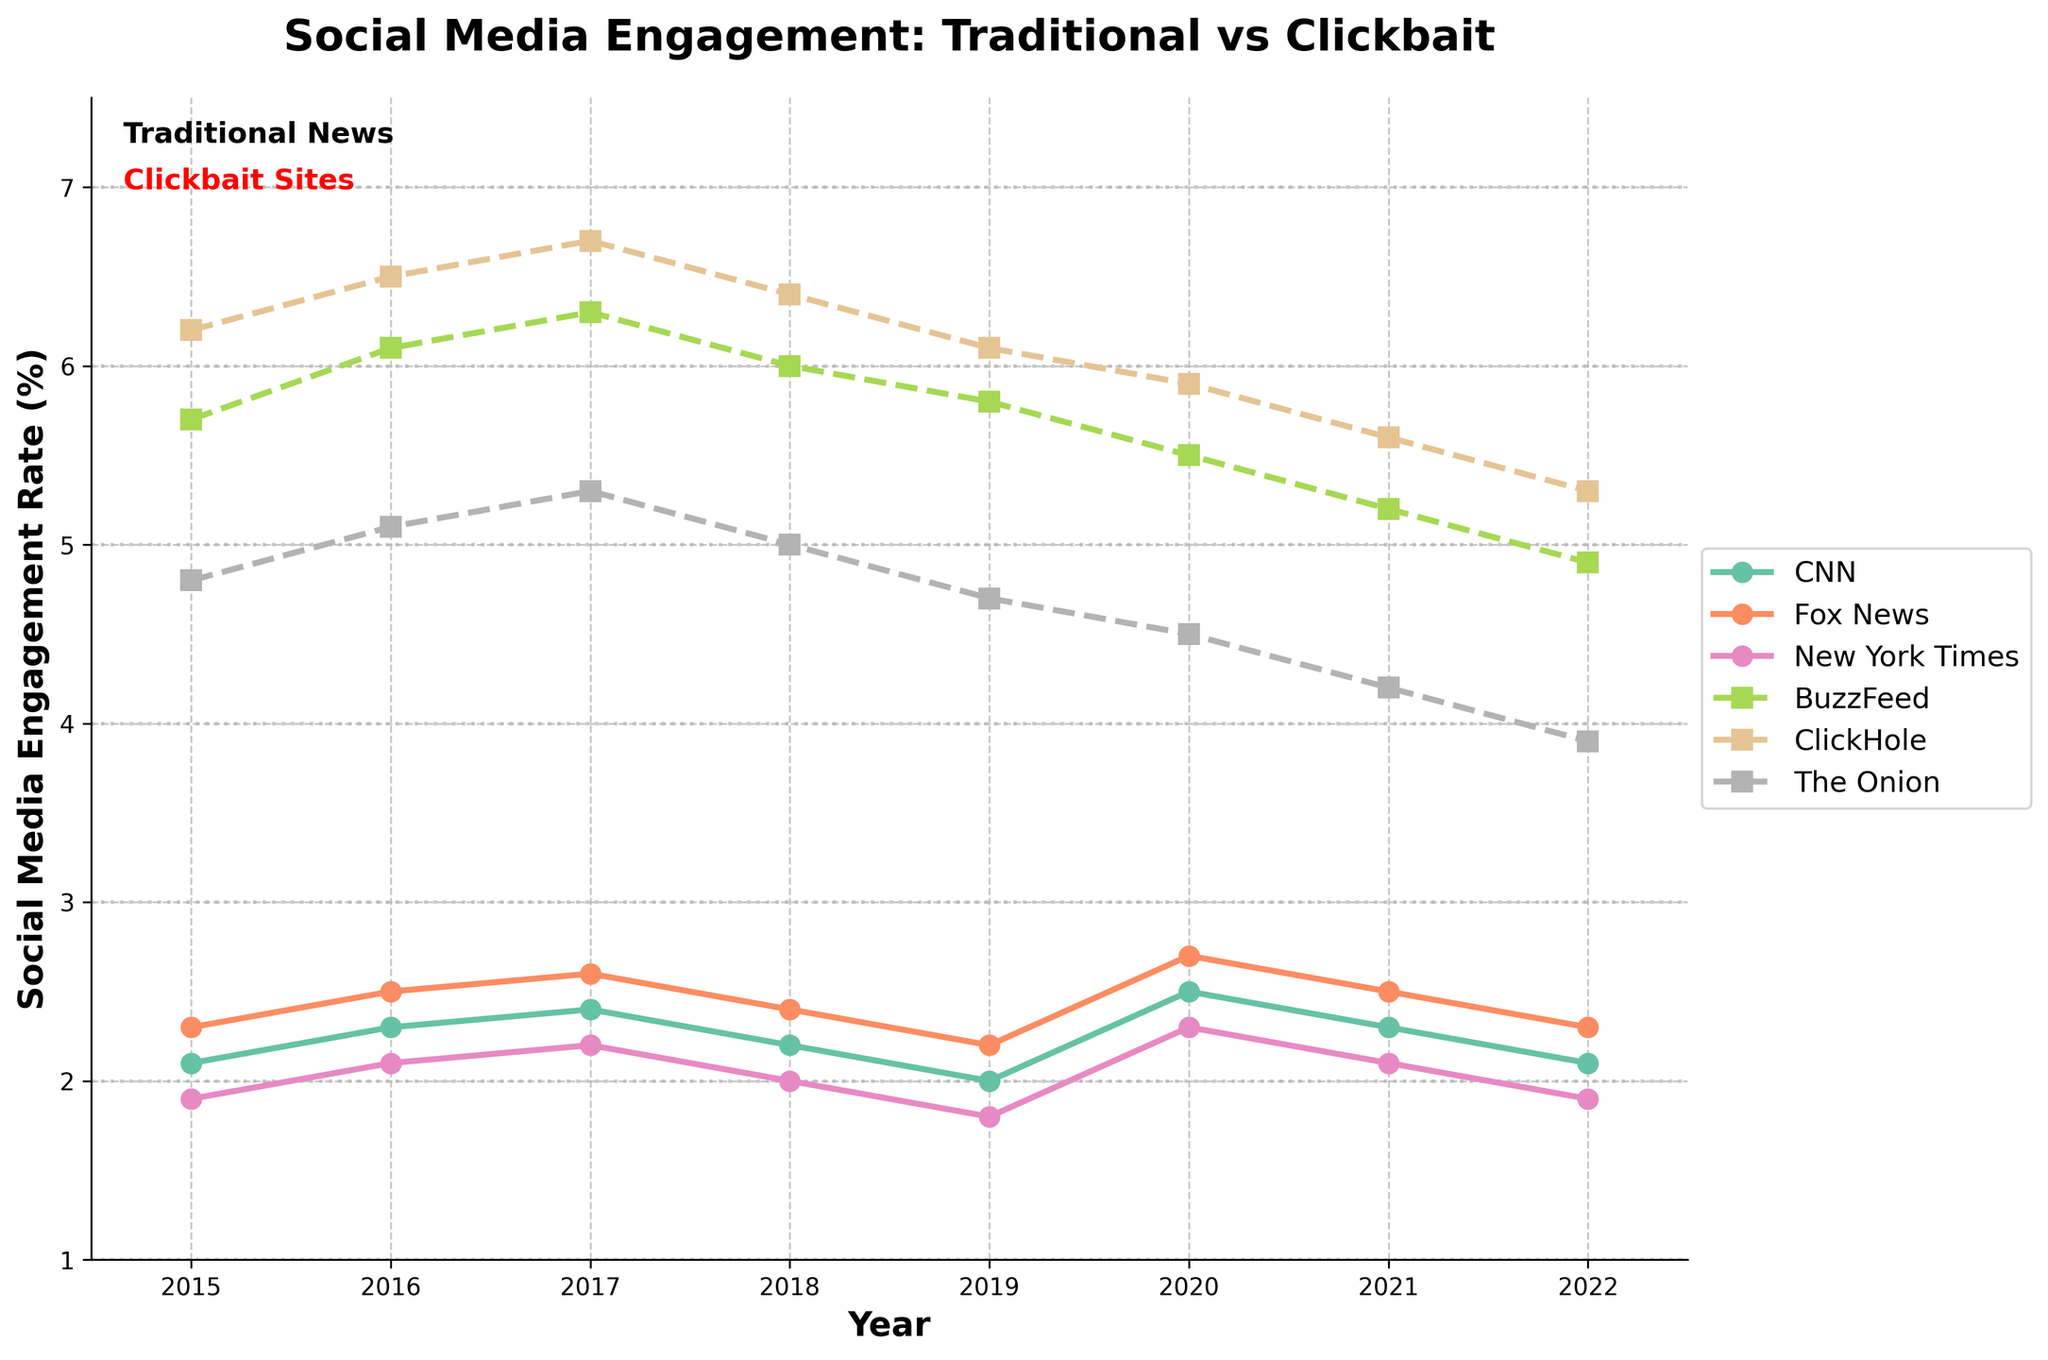Which clickbait site had the highest engagement rate in 2022? Look for the highest value among the clickbait sites (BuzzFeed, ClickHole, The Onion) in the year 2022. BuzzFeed had the highest value at 5.3.
Answer: BuzzFeed In which year did CNN and Fox News both experience their highest engagement rates? Find the peak values for CNN and Fox News and identify the corresponding year. For both, these values are in 2020.
Answer: 2020 What was the average engagement rate of the traditional news outlets (CNN, Fox News, New York Times) in 2017? Add the engagement rates for CNN (2.4), Fox News (2.6), and New York Times (2.2) in 2017, and divide by 3 (i.e., (2.4 + 2.6 + 2.2) / 3).
Answer: 2.4 Did BuzzFeed always have a higher engagement rate than CNN across the years? Compare the engagement rates of BuzzFeed and CNN each year. Yes, BuzzFeed consistently had a higher rate than CNN from 2015 to 2022.
Answer: Yes What color represents the traditional news outlets in the figure? The figure uses specific colors for different categories. Traditional news outlets are mentioned in the textual note as being in black.
Answer: Black Which clickbait site showed the most consistency in engagement rate over the years? Analyze the engagement rates of the clickbait sites to see which one's values change the least over time. ClickHole and The Onion display relatively stable trends but ClickHole shows more consistency (less fluctuation).
Answer: ClickHole 